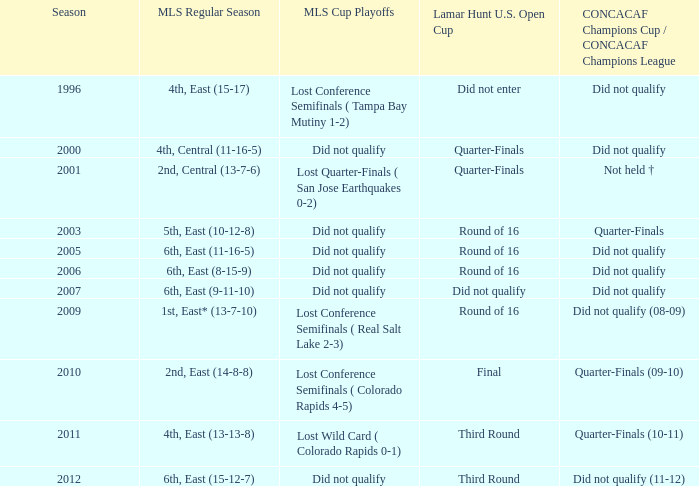Give me the full table as a dictionary. {'header': ['Season', 'MLS Regular Season', 'MLS Cup Playoffs', 'Lamar Hunt U.S. Open Cup', 'CONCACAF Champions Cup / CONCACAF Champions League'], 'rows': [['1996', '4th, East (15-17)', 'Lost Conference Semifinals ( Tampa Bay Mutiny 1-2)', 'Did not enter', 'Did not qualify'], ['2000', '4th, Central (11-16-5)', 'Did not qualify', 'Quarter-Finals', 'Did not qualify'], ['2001', '2nd, Central (13-7-6)', 'Lost Quarter-Finals ( San Jose Earthquakes 0-2)', 'Quarter-Finals', 'Not held †'], ['2003', '5th, East (10-12-8)', 'Did not qualify', 'Round of 16', 'Quarter-Finals'], ['2005', '6th, East (11-16-5)', 'Did not qualify', 'Round of 16', 'Did not qualify'], ['2006', '6th, East (8-15-9)', 'Did not qualify', 'Round of 16', 'Did not qualify'], ['2007', '6th, East (9-11-10)', 'Did not qualify', 'Did not qualify', 'Did not qualify'], ['2009', '1st, East* (13-7-10)', 'Lost Conference Semifinals ( Real Salt Lake 2-3)', 'Round of 16', 'Did not qualify (08-09)'], ['2010', '2nd, East (14-8-8)', 'Lost Conference Semifinals ( Colorado Rapids 4-5)', 'Final', 'Quarter-Finals (09-10)'], ['2011', '4th, East (13-13-8)', 'Lost Wild Card ( Colorado Rapids 0-1)', 'Third Round', 'Quarter-Finals (10-11)'], ['2012', '6th, East (15-12-7)', 'Did not qualify', 'Third Round', 'Did not qualify (11-12)']]} In which season was the mls regular season 6th, east (9-11-10)? 2007.0. 